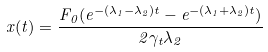<formula> <loc_0><loc_0><loc_500><loc_500>x ( t ) = \frac { F _ { 0 } ( e ^ { - ( \lambda _ { 1 } - \lambda _ { 2 } ) t } - e ^ { - ( \lambda _ { 1 } + \lambda _ { 2 } ) t } ) } { 2 \gamma _ { t } \lambda _ { 2 } }</formula> 